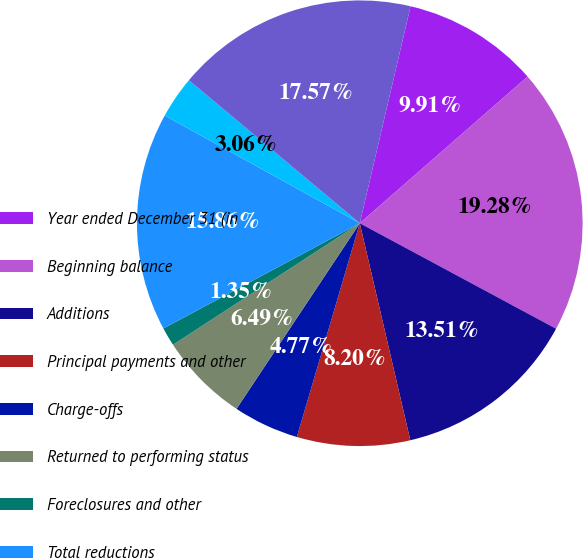Convert chart. <chart><loc_0><loc_0><loc_500><loc_500><pie_chart><fcel>Year ended December 31 (in<fcel>Beginning balance<fcel>Additions<fcel>Principal payments and other<fcel>Charge-offs<fcel>Returned to performing status<fcel>Foreclosures and other<fcel>Total reductions<fcel>Net changes<fcel>Ending balance<nl><fcel>9.91%<fcel>19.28%<fcel>13.51%<fcel>8.2%<fcel>4.77%<fcel>6.49%<fcel>1.35%<fcel>15.86%<fcel>3.06%<fcel>17.57%<nl></chart> 